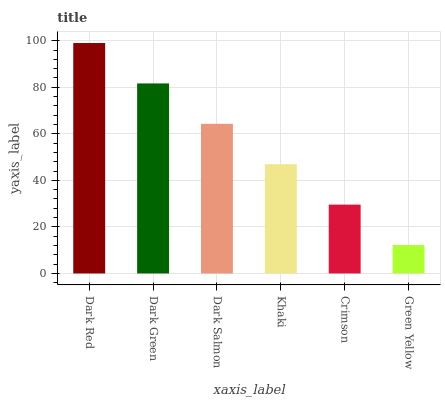Is Green Yellow the minimum?
Answer yes or no. Yes. Is Dark Red the maximum?
Answer yes or no. Yes. Is Dark Green the minimum?
Answer yes or no. No. Is Dark Green the maximum?
Answer yes or no. No. Is Dark Red greater than Dark Green?
Answer yes or no. Yes. Is Dark Green less than Dark Red?
Answer yes or no. Yes. Is Dark Green greater than Dark Red?
Answer yes or no. No. Is Dark Red less than Dark Green?
Answer yes or no. No. Is Dark Salmon the high median?
Answer yes or no. Yes. Is Khaki the low median?
Answer yes or no. Yes. Is Crimson the high median?
Answer yes or no. No. Is Dark Red the low median?
Answer yes or no. No. 